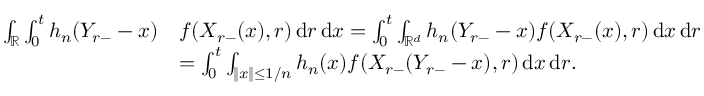Convert formula to latex. <formula><loc_0><loc_0><loc_500><loc_500>\begin{array} { r l } { \int _ { \mathbb { R } } \int _ { 0 } ^ { t } h _ { n } ( Y _ { r - } - x ) } & { f ( X _ { r - } ( x ) , r ) \, d r \, d x = \int _ { 0 } ^ { t } \int _ { \mathbb { R } ^ { d } } h _ { n } ( Y _ { r - } - x ) f ( X _ { r - } ( x ) , r ) \, d x \, d r } \\ & { = \int _ { 0 } ^ { t } \int _ { \| x \| \leq 1 / n } h _ { n } ( x ) f ( X _ { r - } ( Y _ { r - } - x ) , r ) \, d x \, d r . } \end{array}</formula> 